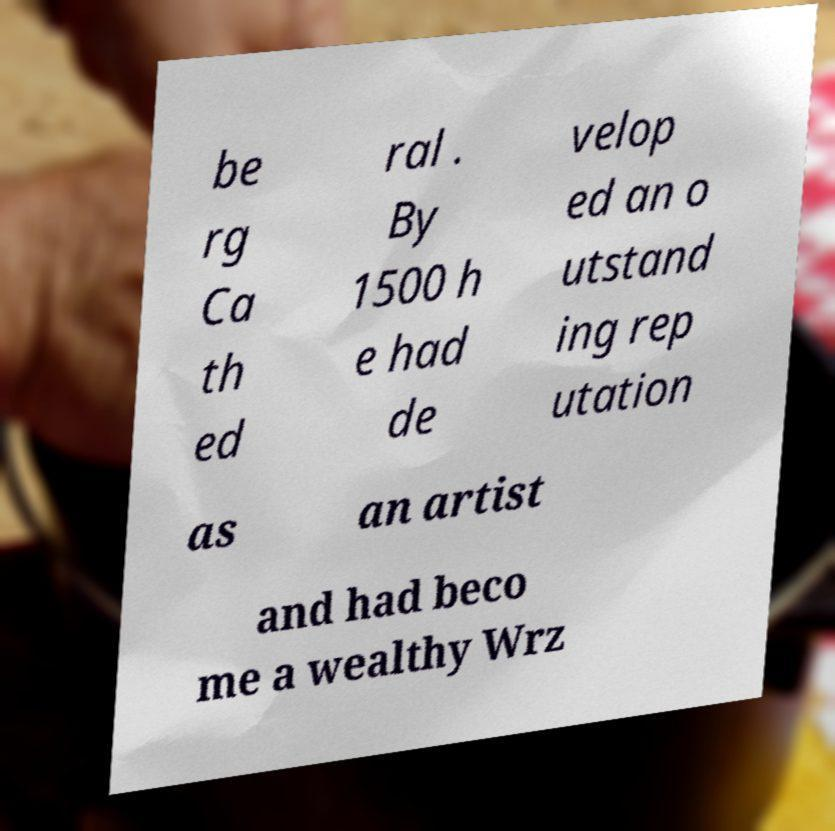Please read and relay the text visible in this image. What does it say? be rg Ca th ed ral . By 1500 h e had de velop ed an o utstand ing rep utation as an artist and had beco me a wealthy Wrz 